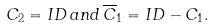Convert formula to latex. <formula><loc_0><loc_0><loc_500><loc_500>C _ { 2 } = I D \, a n d \, \overline { C } _ { 1 } = I D - C _ { 1 } .</formula> 